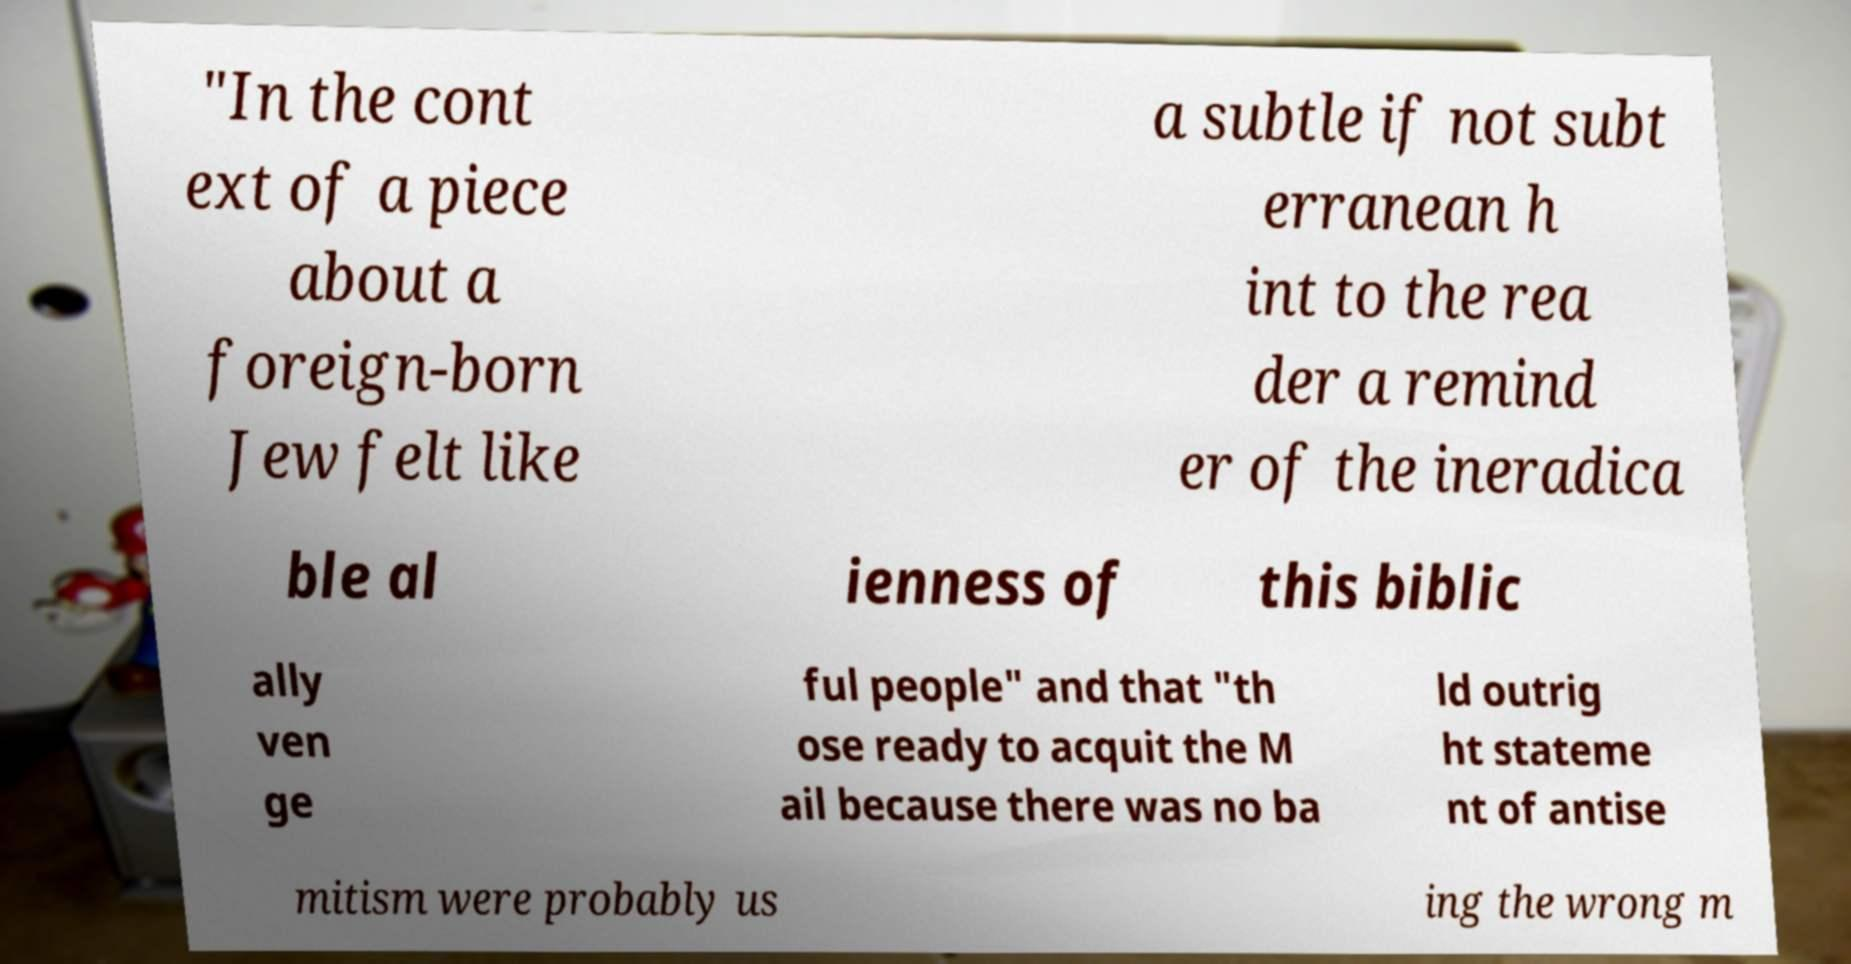Could you extract and type out the text from this image? "In the cont ext of a piece about a foreign-born Jew felt like a subtle if not subt erranean h int to the rea der a remind er of the ineradica ble al ienness of this biblic ally ven ge ful people" and that "th ose ready to acquit the M ail because there was no ba ld outrig ht stateme nt of antise mitism were probably us ing the wrong m 